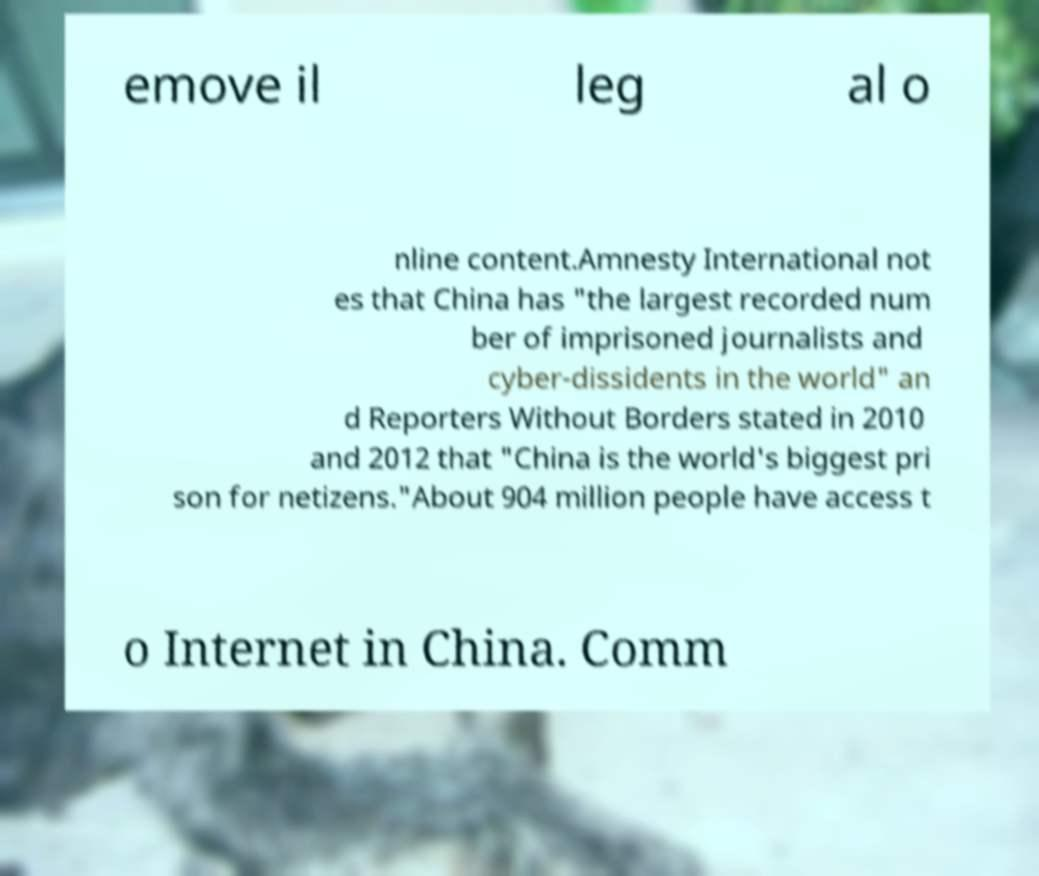Could you extract and type out the text from this image? emove il leg al o nline content.Amnesty International not es that China has "the largest recorded num ber of imprisoned journalists and cyber-dissidents in the world" an d Reporters Without Borders stated in 2010 and 2012 that "China is the world's biggest pri son for netizens."About 904 million people have access t o Internet in China. Comm 